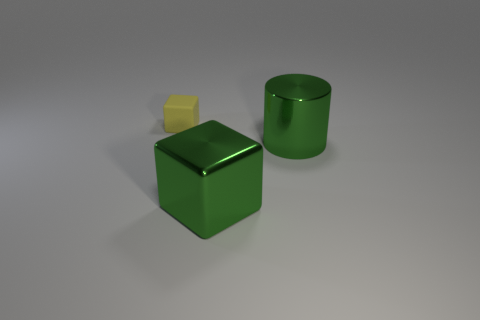Add 2 small rubber things. How many objects exist? 5 Subtract all cylinders. How many objects are left? 2 Add 3 cyan metal objects. How many cyan metal objects exist? 3 Subtract 0 brown spheres. How many objects are left? 3 Subtract all large green metal objects. Subtract all small green rubber blocks. How many objects are left? 1 Add 1 metal cylinders. How many metal cylinders are left? 2 